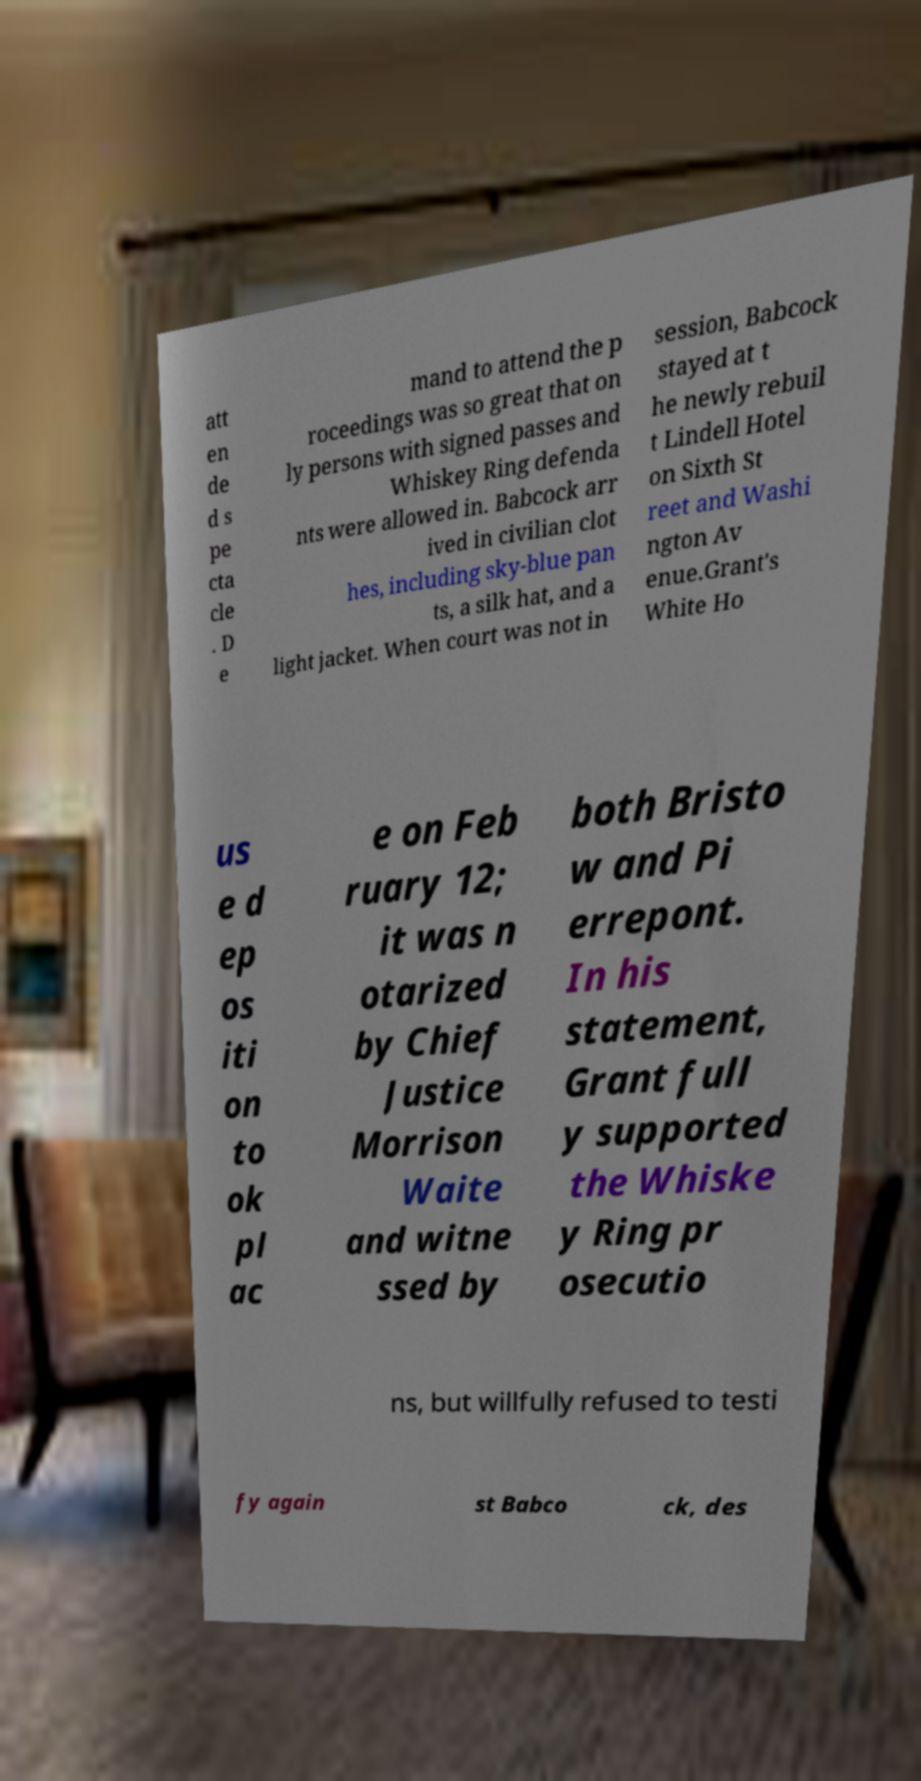There's text embedded in this image that I need extracted. Can you transcribe it verbatim? att en de d s pe cta cle . D e mand to attend the p roceedings was so great that on ly persons with signed passes and Whiskey Ring defenda nts were allowed in. Babcock arr ived in civilian clot hes, including sky-blue pan ts, a silk hat, and a light jacket. When court was not in session, Babcock stayed at t he newly rebuil t Lindell Hotel on Sixth St reet and Washi ngton Av enue.Grant's White Ho us e d ep os iti on to ok pl ac e on Feb ruary 12; it was n otarized by Chief Justice Morrison Waite and witne ssed by both Bristo w and Pi errepont. In his statement, Grant full y supported the Whiske y Ring pr osecutio ns, but willfully refused to testi fy again st Babco ck, des 